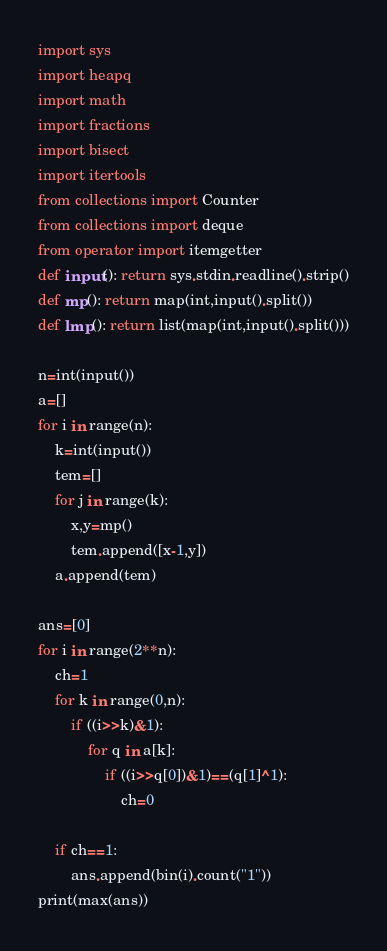Convert code to text. <code><loc_0><loc_0><loc_500><loc_500><_Python_>import sys
import heapq
import math
import fractions
import bisect
import itertools
from collections import Counter
from collections import deque
from operator import itemgetter
def input(): return sys.stdin.readline().strip()
def mp(): return map(int,input().split())
def lmp(): return list(map(int,input().split()))

n=int(input())
a=[]
for i in range(n):
    k=int(input())
    tem=[]
    for j in range(k):
        x,y=mp()
        tem.append([x-1,y])
    a.append(tem)

ans=[0]
for i in range(2**n):
    ch=1
    for k in range(0,n):
        if ((i>>k)&1):
            for q in a[k]:
                if ((i>>q[0])&1)==(q[1]^1):
                    ch=0

    if ch==1:
        ans.append(bin(i).count("1"))
print(max(ans))</code> 